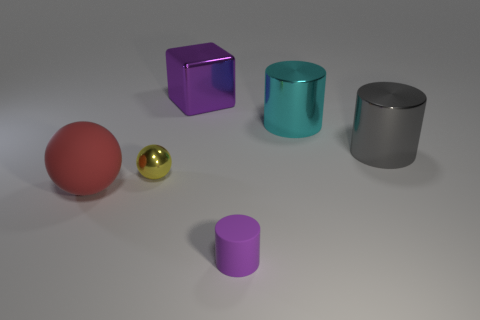Are there more large cyan things than big purple spheres?
Ensure brevity in your answer.  Yes. What color is the metal sphere?
Offer a terse response. Yellow. There is a rubber thing to the left of the purple cylinder; is its color the same as the tiny ball?
Give a very brief answer. No. What material is the object that is the same color as the cube?
Your answer should be compact. Rubber. What number of objects are the same color as the tiny cylinder?
Make the answer very short. 1. Do the purple thing in front of the big red rubber ball and the large red matte thing have the same shape?
Give a very brief answer. No. Is the number of big cyan metallic cylinders behind the purple metal block less than the number of cubes right of the cyan shiny cylinder?
Give a very brief answer. No. What is the cylinder in front of the large red matte ball made of?
Ensure brevity in your answer.  Rubber. What size is the object that is the same color as the small cylinder?
Make the answer very short. Large. Is there a shiny object that has the same size as the purple cylinder?
Keep it short and to the point. Yes. 